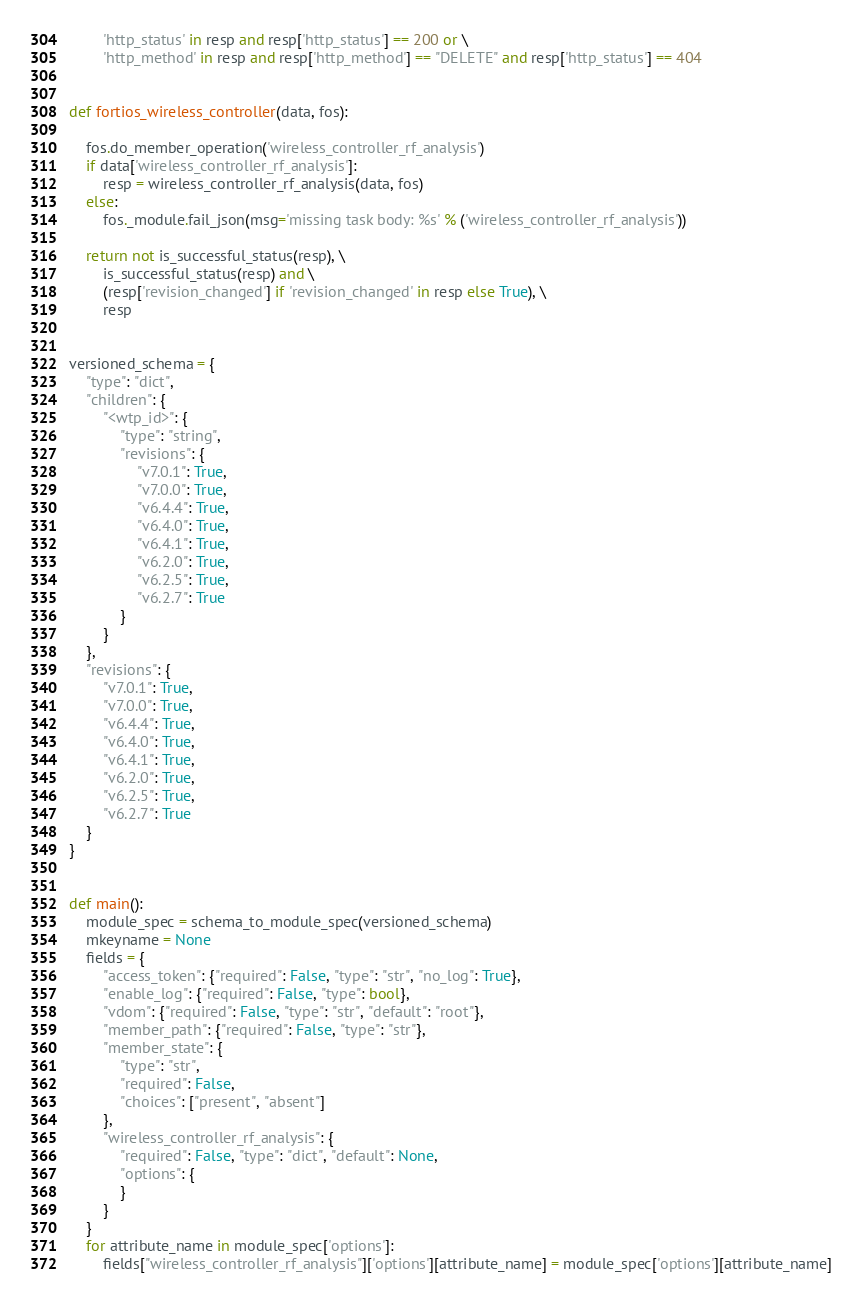<code> <loc_0><loc_0><loc_500><loc_500><_Python_>        'http_status' in resp and resp['http_status'] == 200 or \
        'http_method' in resp and resp['http_method'] == "DELETE" and resp['http_status'] == 404


def fortios_wireless_controller(data, fos):

    fos.do_member_operation('wireless_controller_rf_analysis')
    if data['wireless_controller_rf_analysis']:
        resp = wireless_controller_rf_analysis(data, fos)
    else:
        fos._module.fail_json(msg='missing task body: %s' % ('wireless_controller_rf_analysis'))

    return not is_successful_status(resp), \
        is_successful_status(resp) and \
        (resp['revision_changed'] if 'revision_changed' in resp else True), \
        resp


versioned_schema = {
    "type": "dict",
    "children": {
        "<wtp_id>": {
            "type": "string",
            "revisions": {
                "v7.0.1": True,
                "v7.0.0": True,
                "v6.4.4": True,
                "v6.4.0": True,
                "v6.4.1": True,
                "v6.2.0": True,
                "v6.2.5": True,
                "v6.2.7": True
            }
        }
    },
    "revisions": {
        "v7.0.1": True,
        "v7.0.0": True,
        "v6.4.4": True,
        "v6.4.0": True,
        "v6.4.1": True,
        "v6.2.0": True,
        "v6.2.5": True,
        "v6.2.7": True
    }
}


def main():
    module_spec = schema_to_module_spec(versioned_schema)
    mkeyname = None
    fields = {
        "access_token": {"required": False, "type": "str", "no_log": True},
        "enable_log": {"required": False, "type": bool},
        "vdom": {"required": False, "type": "str", "default": "root"},
        "member_path": {"required": False, "type": "str"},
        "member_state": {
            "type": "str",
            "required": False,
            "choices": ["present", "absent"]
        },
        "wireless_controller_rf_analysis": {
            "required": False, "type": "dict", "default": None,
            "options": {
            }
        }
    }
    for attribute_name in module_spec['options']:
        fields["wireless_controller_rf_analysis"]['options'][attribute_name] = module_spec['options'][attribute_name]</code> 